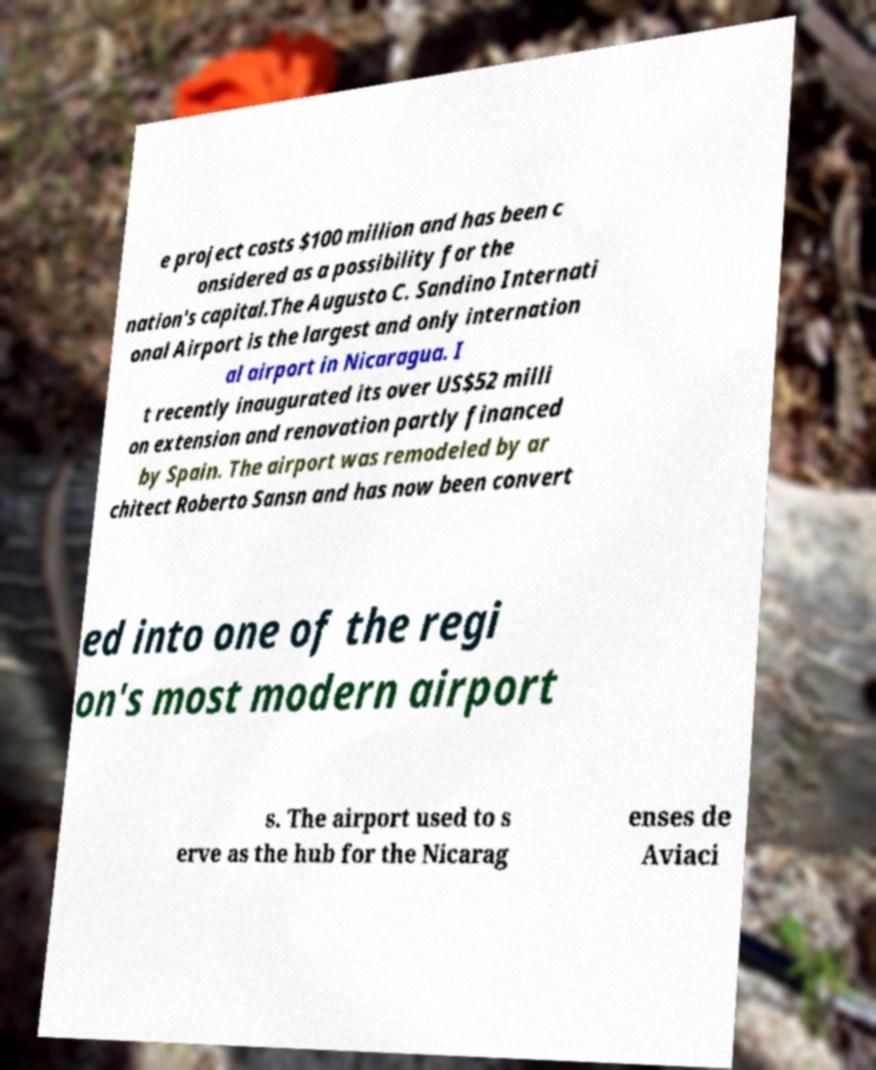I need the written content from this picture converted into text. Can you do that? e project costs $100 million and has been c onsidered as a possibility for the nation's capital.The Augusto C. Sandino Internati onal Airport is the largest and only internation al airport in Nicaragua. I t recently inaugurated its over US$52 milli on extension and renovation partly financed by Spain. The airport was remodeled by ar chitect Roberto Sansn and has now been convert ed into one of the regi on's most modern airport s. The airport used to s erve as the hub for the Nicarag enses de Aviaci 